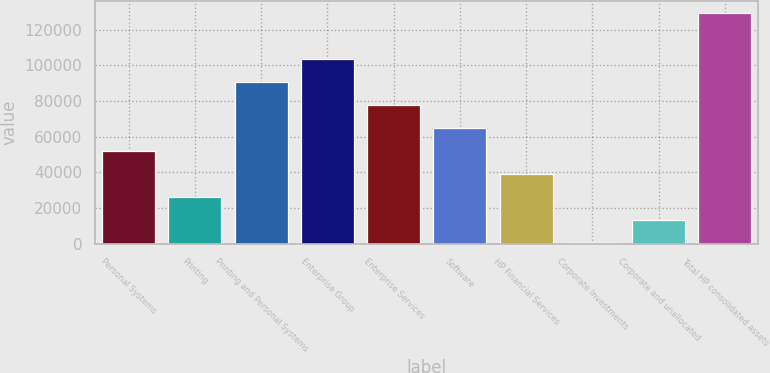Convert chart to OTSL. <chart><loc_0><loc_0><loc_500><loc_500><bar_chart><fcel>Personal Systems<fcel>Printing<fcel>Printing and Personal Systems<fcel>Enterprise Group<fcel>Enterprise Services<fcel>Software<fcel>HP Financial Services<fcel>Corporate Investments<fcel>Corporate and unallocated<fcel>Total HP consolidated assets<nl><fcel>52117<fcel>26317<fcel>90817<fcel>103717<fcel>77917<fcel>65017<fcel>39217<fcel>517<fcel>13417<fcel>129517<nl></chart> 